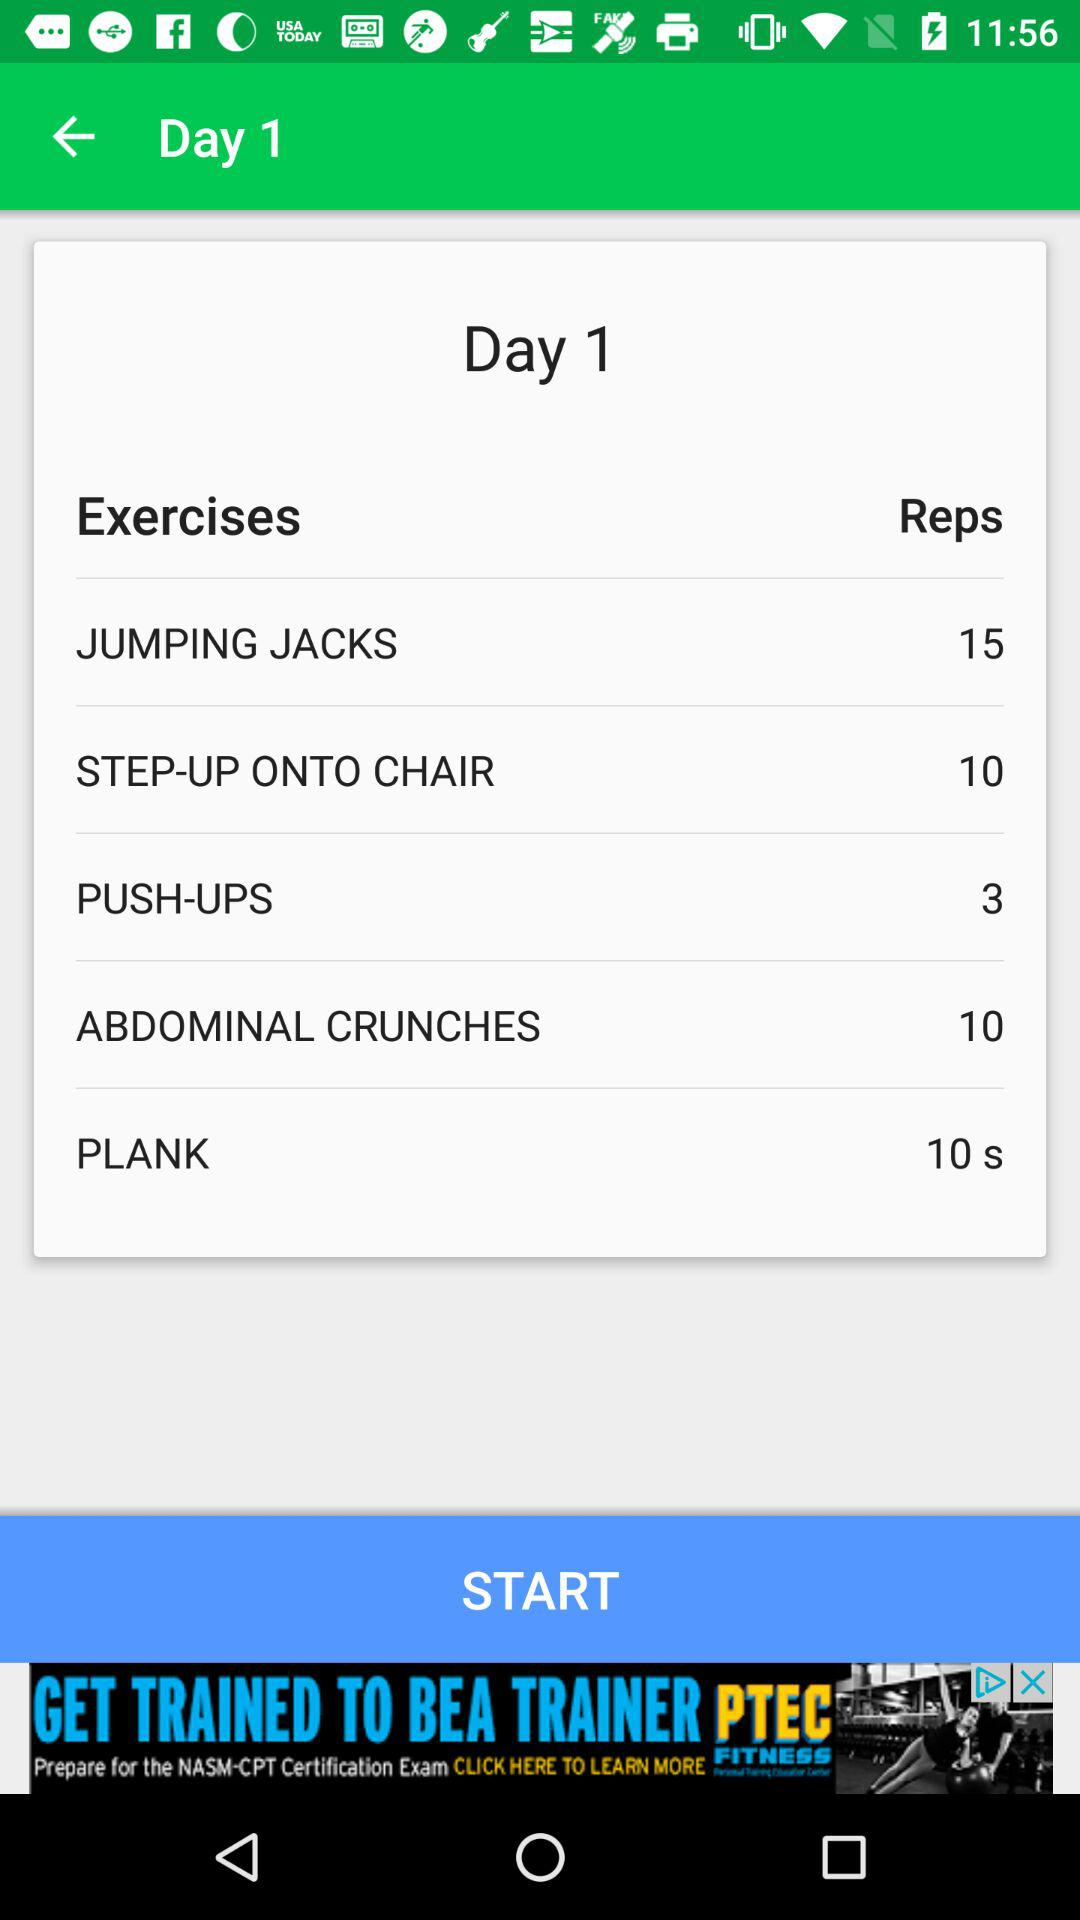What is the set duration for plank? The set duration is 10 seconds. 